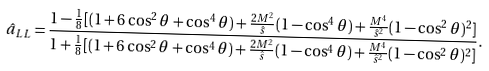<formula> <loc_0><loc_0><loc_500><loc_500>\hat { a } _ { L L } = \frac { 1 - \frac { 1 } { 8 } [ ( 1 + 6 \cos ^ { 2 } \theta + \cos ^ { 4 } \theta ) + \frac { 2 M ^ { 2 } } { \hat { s } } ( 1 - \cos ^ { 4 } \theta ) + \frac { M ^ { 4 } } { \hat { s } ^ { 2 } } ( 1 - \cos ^ { 2 } \theta ) ^ { 2 } ] } { 1 + \frac { 1 } { 8 } [ ( 1 + 6 \cos ^ { 2 } \theta + \cos ^ { 4 } \theta ) + \frac { 2 M ^ { 2 } } { \hat { s } } ( 1 - \cos ^ { 4 } \theta ) + \frac { M ^ { 4 } } { \hat { s } ^ { 2 } } ( 1 - \cos ^ { 2 } \theta ) ^ { 2 } ] } .</formula> 